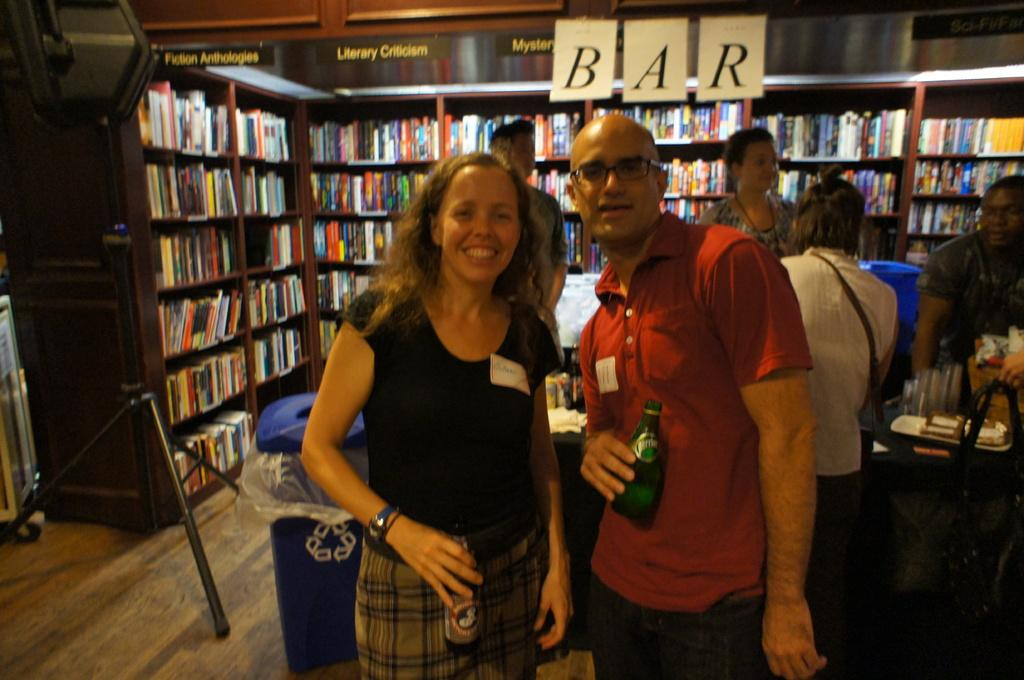Where was the image taken? The image was taken in a room. What are the people in the image doing? The group of people is standing on the floor and holding a bottle. What can be seen in the background of the image? There is a shelf with books in the background. What type of son can be heard singing in the image? There is no son or singing present in the image; it only shows a group of people holding a bottle in a room with a shelf of books in the background. 